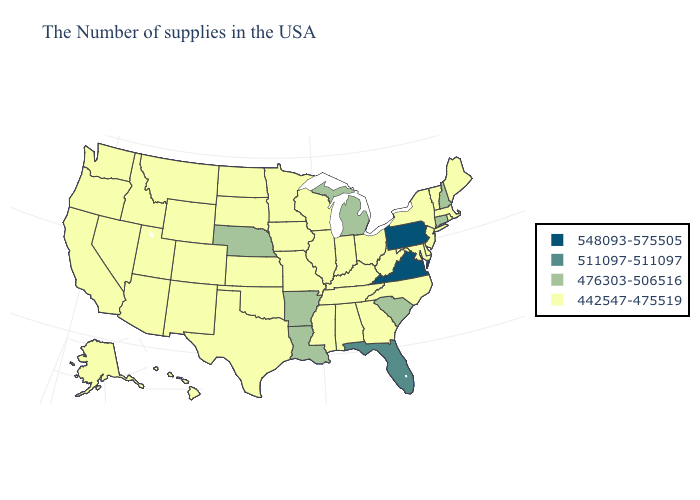What is the lowest value in the USA?
Write a very short answer. 442547-475519. What is the value of Connecticut?
Answer briefly. 476303-506516. Name the states that have a value in the range 511097-511097?
Short answer required. Florida. Among the states that border Louisiana , does Texas have the highest value?
Concise answer only. No. Among the states that border Colorado , does Arizona have the lowest value?
Concise answer only. Yes. Among the states that border Wisconsin , does Illinois have the highest value?
Be succinct. No. Does the map have missing data?
Give a very brief answer. No. Which states hav the highest value in the Northeast?
Concise answer only. Pennsylvania. Among the states that border Rhode Island , does Connecticut have the lowest value?
Give a very brief answer. No. Which states have the highest value in the USA?
Short answer required. Pennsylvania, Virginia. Does the map have missing data?
Short answer required. No. What is the value of Wyoming?
Concise answer only. 442547-475519. What is the value of Minnesota?
Answer briefly. 442547-475519. Name the states that have a value in the range 476303-506516?
Concise answer only. New Hampshire, Connecticut, South Carolina, Michigan, Louisiana, Arkansas, Nebraska. Which states hav the highest value in the Northeast?
Answer briefly. Pennsylvania. 